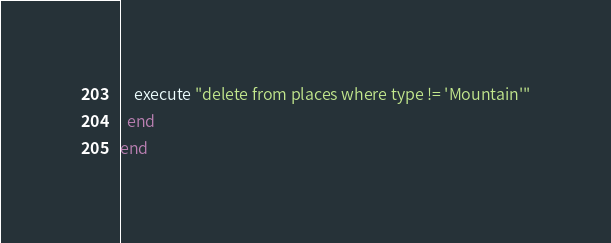<code> <loc_0><loc_0><loc_500><loc_500><_Ruby_>    execute "delete from places where type != 'Mountain'"
  end
end
</code> 